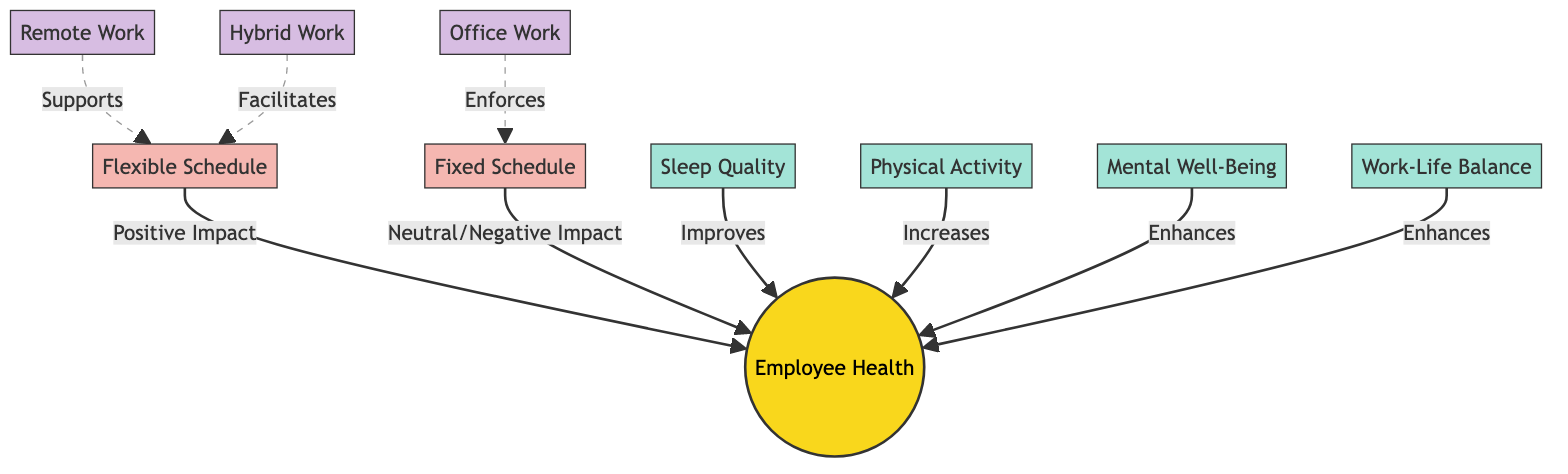What is the impact of a flexible schedule on employee health? According to the diagram, a flexible schedule has a "Positive Impact" on employee health, indicating that it enhances overall well-being.
Answer: Positive Impact How many factors influence employee health? The diagram shows four factors that influence employee health: Sleep Quality, Physical Activity, Mental Well-Being, and Work-Life Balance. This totals four specific factors.
Answer: 4 What type of work schedule enforces a fixed schedule? The diagram indicates that "Office Work" is associated with enforcing a fixed schedule. Therefore, it is the type of work that mandates a fixed schedule.
Answer: Office Work What role does remote work play in relation to flexible schedules? The diagram illustrates that remote work "Supports" flexible schedules, indicating it helps facilitate this type of working arrangement.
Answer: Supports Which factor enhances employee health and is related to balance in life? "Work-Life Balance" is listed as a factor that enhances employee health and is directly associated with achieving a balance between personal and professional responsibilities.
Answer: Work-Life Balance What is the overall effect of a fixed schedule on employee health? The diagram states that a fixed schedule has a "Neutral/Negative Impact" on employee health, suggesting that it does not improve or may detrimentally affect well-being.
Answer: Neutral/Negative Impact How does hybrid work relate to flexible schedules? The diagram shows that hybrid work "Facilitates" flexible schedules, indicating that it makes it easier for employees to have flexible working options.
Answer: Facilitates Which two conditions support a flexible schedule? The diagram lists "Remote Work" and "Hybrid Work" as conditions that support a flexible schedule. Both conditions enable a more adaptable working arrangement.
Answer: Remote Work, Hybrid Work What is the relationship between mental well-being and employee health? The diagram states that mental well-being "Enhances" employee health, indicating that improvements in mental well-being positively affect overall health.
Answer: Enhances 